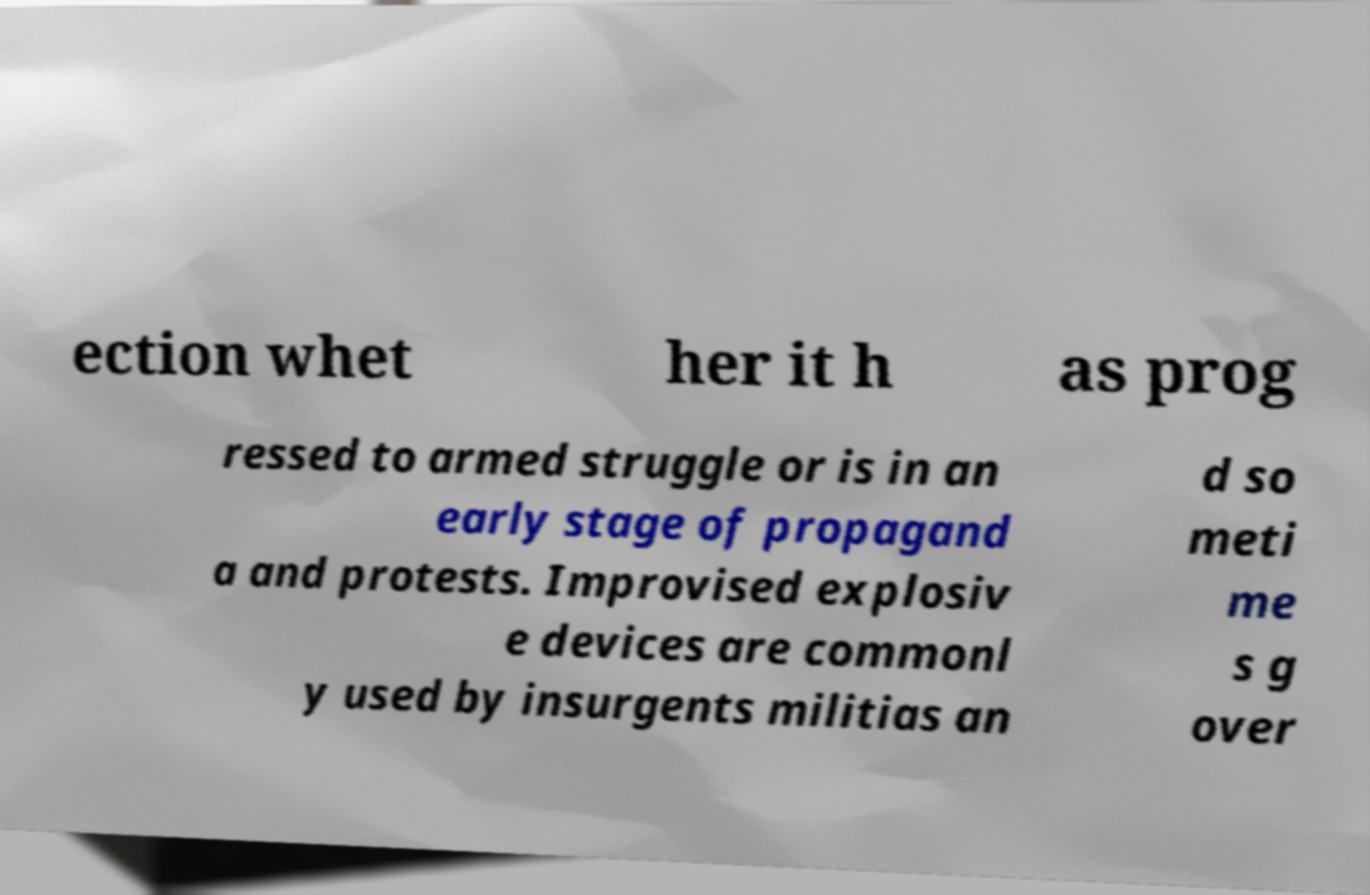There's text embedded in this image that I need extracted. Can you transcribe it verbatim? ection whet her it h as prog ressed to armed struggle or is in an early stage of propagand a and protests. Improvised explosiv e devices are commonl y used by insurgents militias an d so meti me s g over 